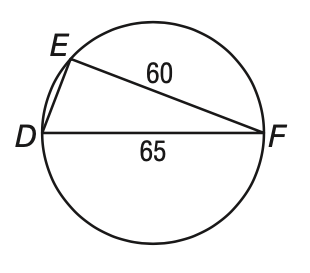Answer the mathemtical geometry problem and directly provide the correct option letter.
Question: What is E D?
Choices: A: 15 B: 25 C: 88.5 D: not enough information D 